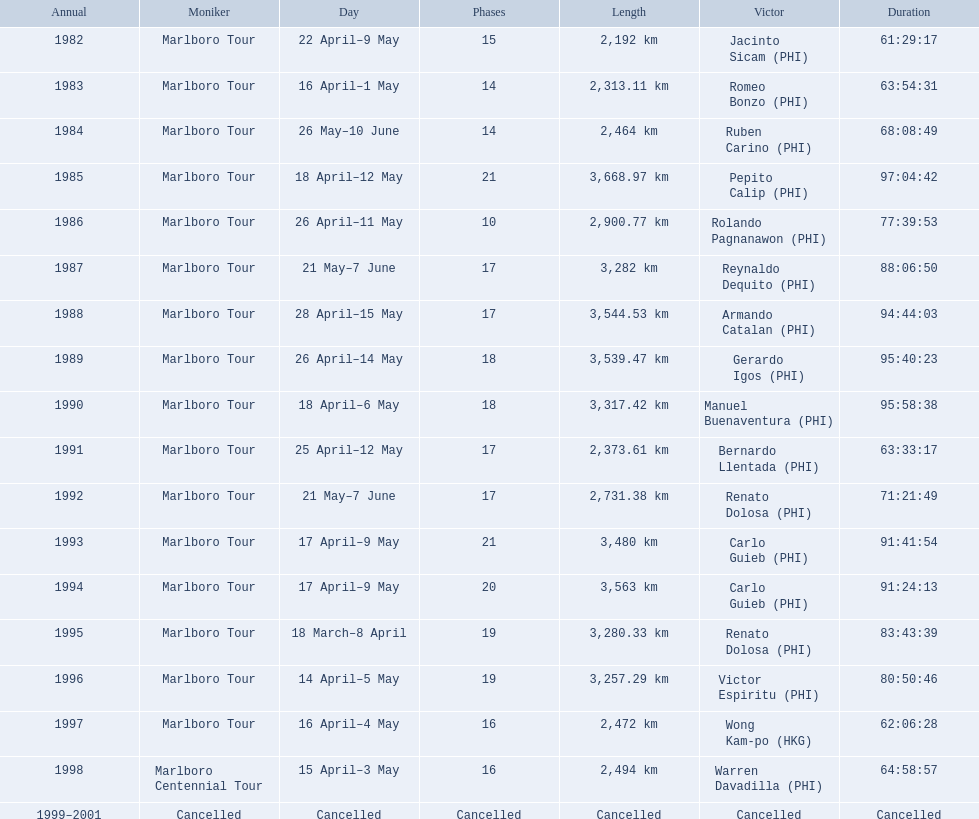How far did the marlboro tour travel each year? 2,192 km, 2,313.11 km, 2,464 km, 3,668.97 km, 2,900.77 km, 3,282 km, 3,544.53 km, 3,539.47 km, 3,317.42 km, 2,373.61 km, 2,731.38 km, 3,480 km, 3,563 km, 3,280.33 km, 3,257.29 km, 2,472 km, 2,494 km, Cancelled. In what year did they travel the furthest? 1985. Can you give me this table in json format? {'header': ['Annual', 'Moniker', 'Day', 'Phases', 'Length', 'Victor', 'Duration'], 'rows': [['1982', 'Marlboro Tour', '22 April–9 May', '15', '2,192\xa0km', 'Jacinto Sicam\xa0(PHI)', '61:29:17'], ['1983', 'Marlboro Tour', '16 April–1 May', '14', '2,313.11\xa0km', 'Romeo Bonzo\xa0(PHI)', '63:54:31'], ['1984', 'Marlboro Tour', '26 May–10 June', '14', '2,464\xa0km', 'Ruben Carino\xa0(PHI)', '68:08:49'], ['1985', 'Marlboro Tour', '18 April–12 May', '21', '3,668.97\xa0km', 'Pepito Calip\xa0(PHI)', '97:04:42'], ['1986', 'Marlboro Tour', '26 April–11 May', '10', '2,900.77\xa0km', 'Rolando Pagnanawon\xa0(PHI)', '77:39:53'], ['1987', 'Marlboro Tour', '21 May–7 June', '17', '3,282\xa0km', 'Reynaldo Dequito\xa0(PHI)', '88:06:50'], ['1988', 'Marlboro Tour', '28 April–15 May', '17', '3,544.53\xa0km', 'Armando Catalan\xa0(PHI)', '94:44:03'], ['1989', 'Marlboro Tour', '26 April–14 May', '18', '3,539.47\xa0km', 'Gerardo Igos\xa0(PHI)', '95:40:23'], ['1990', 'Marlboro Tour', '18 April–6 May', '18', '3,317.42\xa0km', 'Manuel Buenaventura\xa0(PHI)', '95:58:38'], ['1991', 'Marlboro Tour', '25 April–12 May', '17', '2,373.61\xa0km', 'Bernardo Llentada\xa0(PHI)', '63:33:17'], ['1992', 'Marlboro Tour', '21 May–7 June', '17', '2,731.38\xa0km', 'Renato Dolosa\xa0(PHI)', '71:21:49'], ['1993', 'Marlboro Tour', '17 April–9 May', '21', '3,480\xa0km', 'Carlo Guieb\xa0(PHI)', '91:41:54'], ['1994', 'Marlboro Tour', '17 April–9 May', '20', '3,563\xa0km', 'Carlo Guieb\xa0(PHI)', '91:24:13'], ['1995', 'Marlboro Tour', '18 March–8 April', '19', '3,280.33\xa0km', 'Renato Dolosa\xa0(PHI)', '83:43:39'], ['1996', 'Marlboro Tour', '14 April–5 May', '19', '3,257.29\xa0km', 'Victor Espiritu\xa0(PHI)', '80:50:46'], ['1997', 'Marlboro Tour', '16 April–4 May', '16', '2,472\xa0km', 'Wong Kam-po\xa0(HKG)', '62:06:28'], ['1998', 'Marlboro Centennial Tour', '15 April–3 May', '16', '2,494\xa0km', 'Warren Davadilla\xa0(PHI)', '64:58:57'], ['1999–2001', 'Cancelled', 'Cancelled', 'Cancelled', 'Cancelled', 'Cancelled', 'Cancelled']]} How far did they travel that year? 3,668.97 km. 